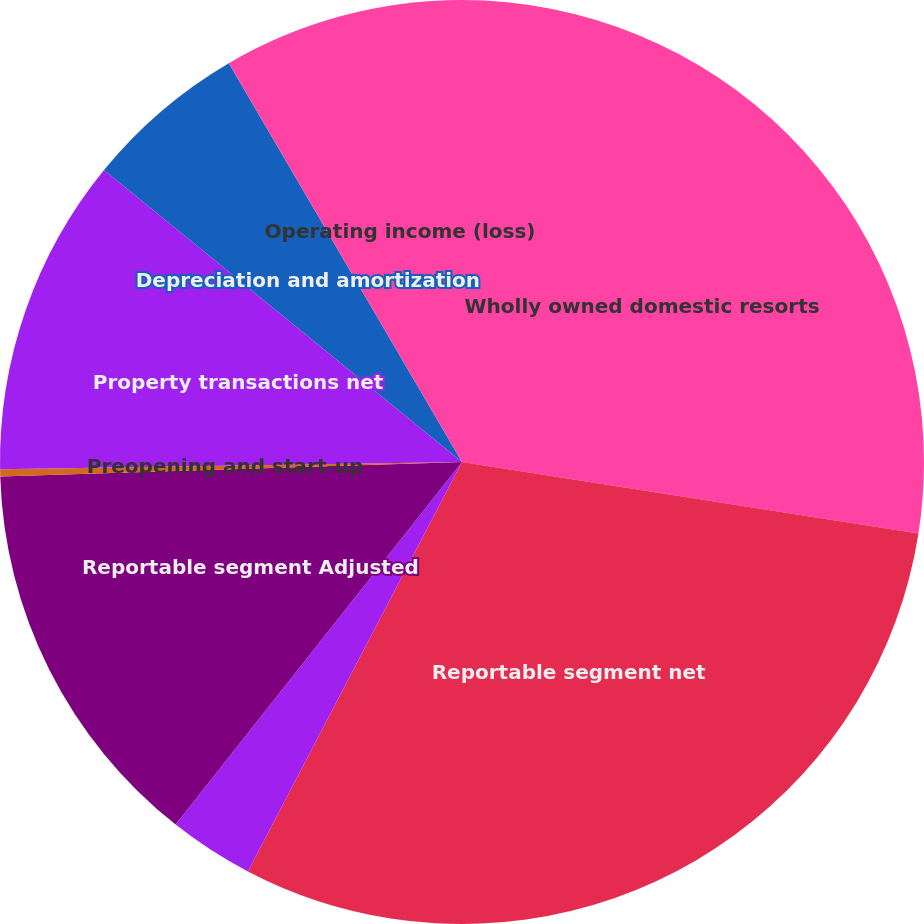Convert chart. <chart><loc_0><loc_0><loc_500><loc_500><pie_chart><fcel>Wholly owned domestic resorts<fcel>Reportable segment net<fcel>Corporate and other<fcel>Reportable segment Adjusted<fcel>Preopening and start-up<fcel>Property transactions net<fcel>Depreciation and amortization<fcel>Operating income (loss)<nl><fcel>27.47%<fcel>30.2%<fcel>2.97%<fcel>13.86%<fcel>0.25%<fcel>11.14%<fcel>5.69%<fcel>8.42%<nl></chart> 